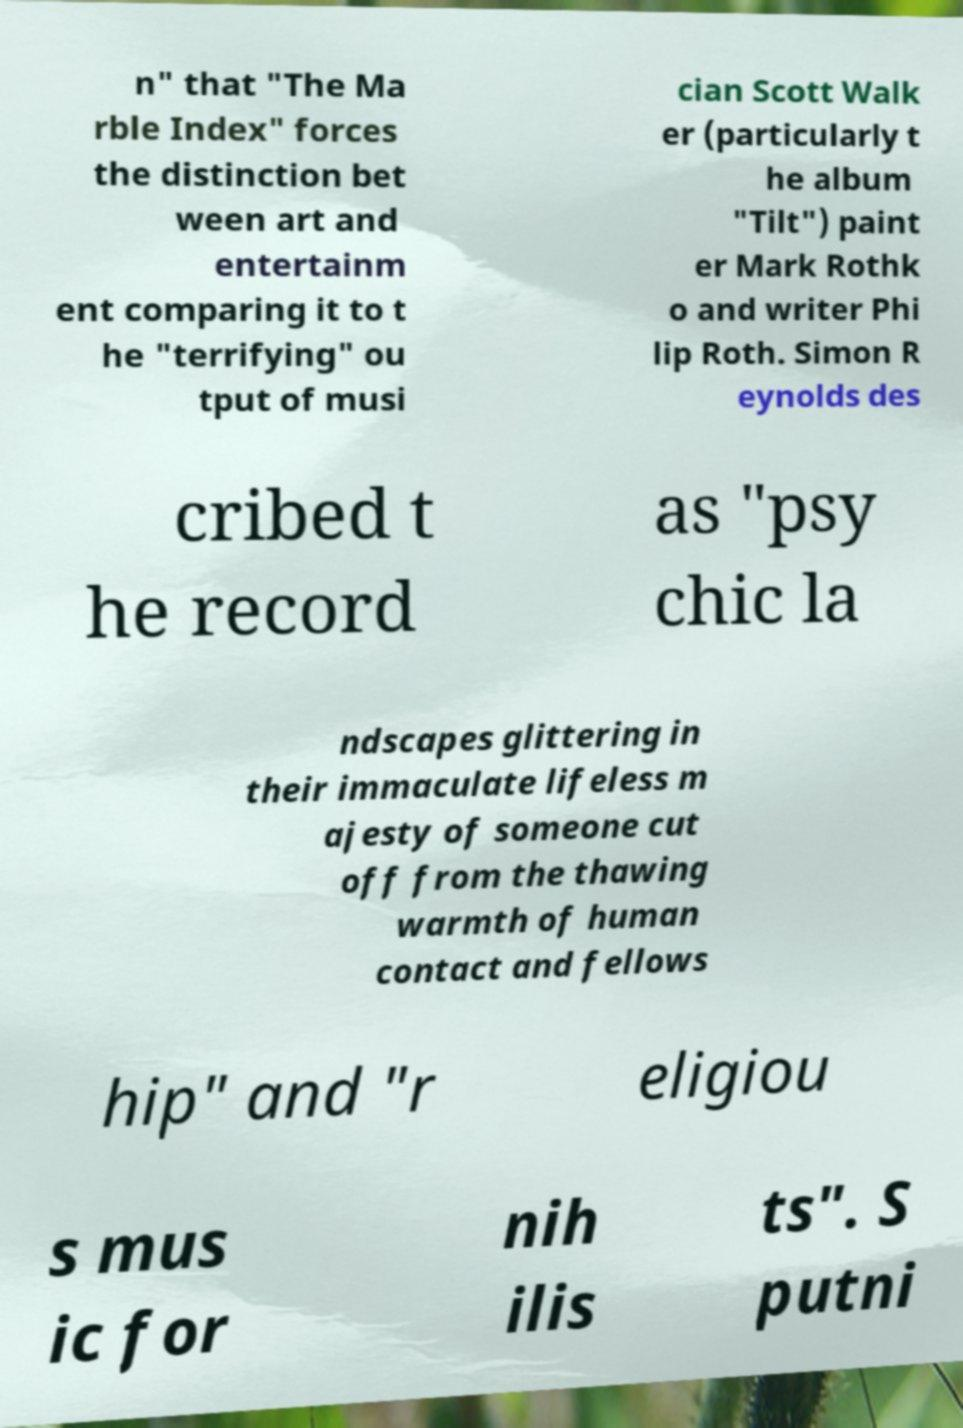I need the written content from this picture converted into text. Can you do that? n" that "The Ma rble Index" forces the distinction bet ween art and entertainm ent comparing it to t he "terrifying" ou tput of musi cian Scott Walk er (particularly t he album "Tilt") paint er Mark Rothk o and writer Phi lip Roth. Simon R eynolds des cribed t he record as "psy chic la ndscapes glittering in their immaculate lifeless m ajesty of someone cut off from the thawing warmth of human contact and fellows hip" and "r eligiou s mus ic for nih ilis ts". S putni 